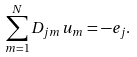Convert formula to latex. <formula><loc_0><loc_0><loc_500><loc_500>\sum _ { m = 1 } ^ { N } { D _ { j m } u _ { m } } = - e _ { j } .</formula> 